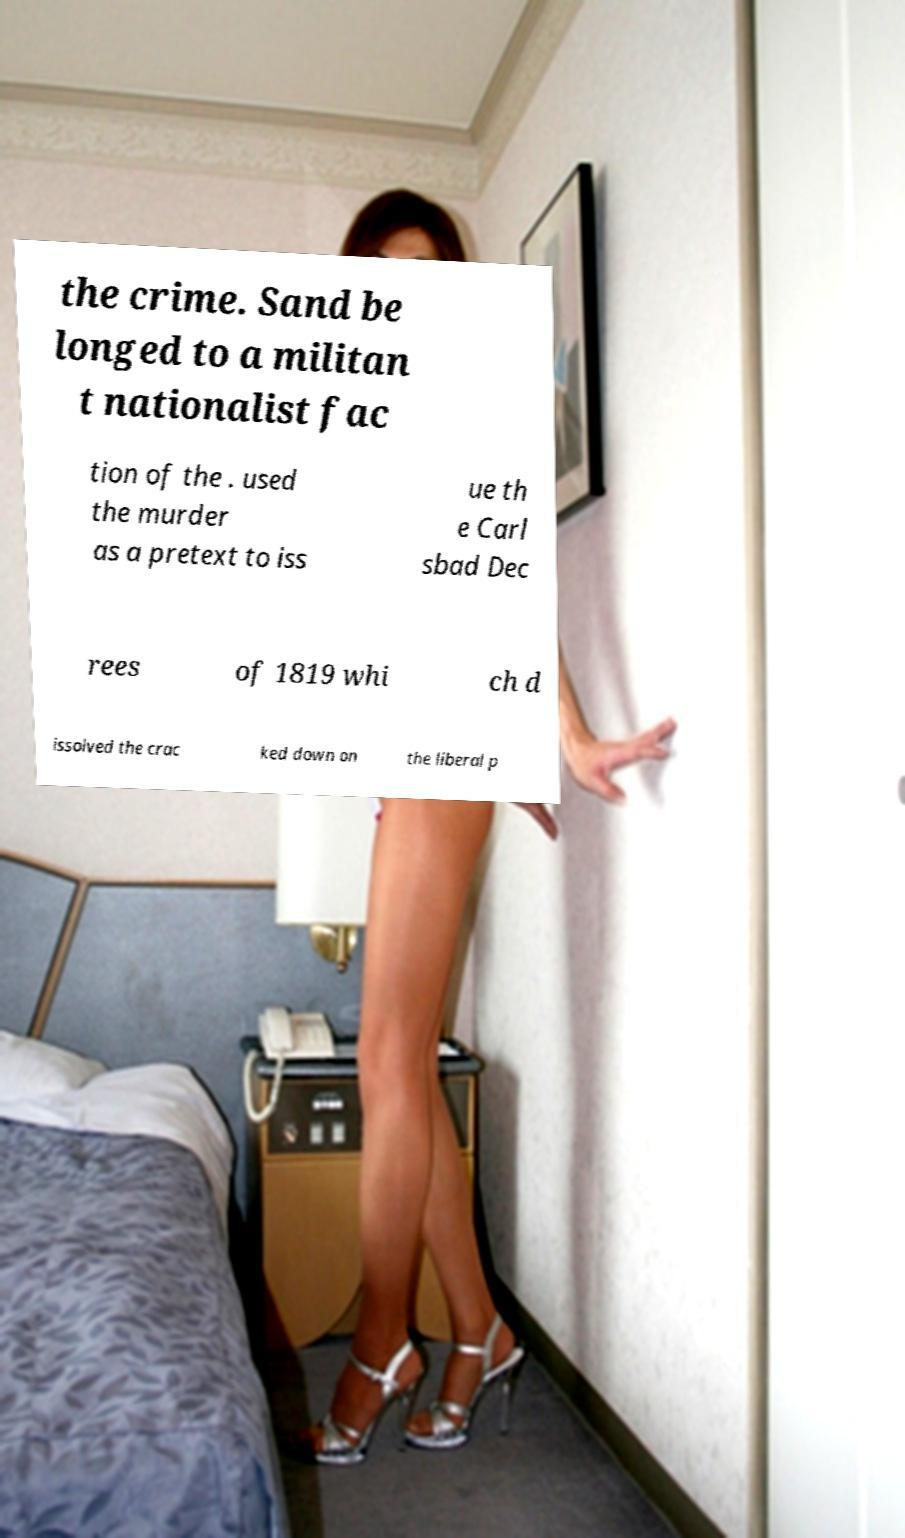Could you assist in decoding the text presented in this image and type it out clearly? the crime. Sand be longed to a militan t nationalist fac tion of the . used the murder as a pretext to iss ue th e Carl sbad Dec rees of 1819 whi ch d issolved the crac ked down on the liberal p 